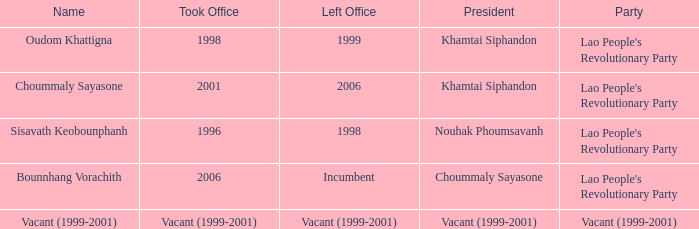What is Name, when President is Khamtai Siphandon, and when Left Office is 1999? Oudom Khattigna. 